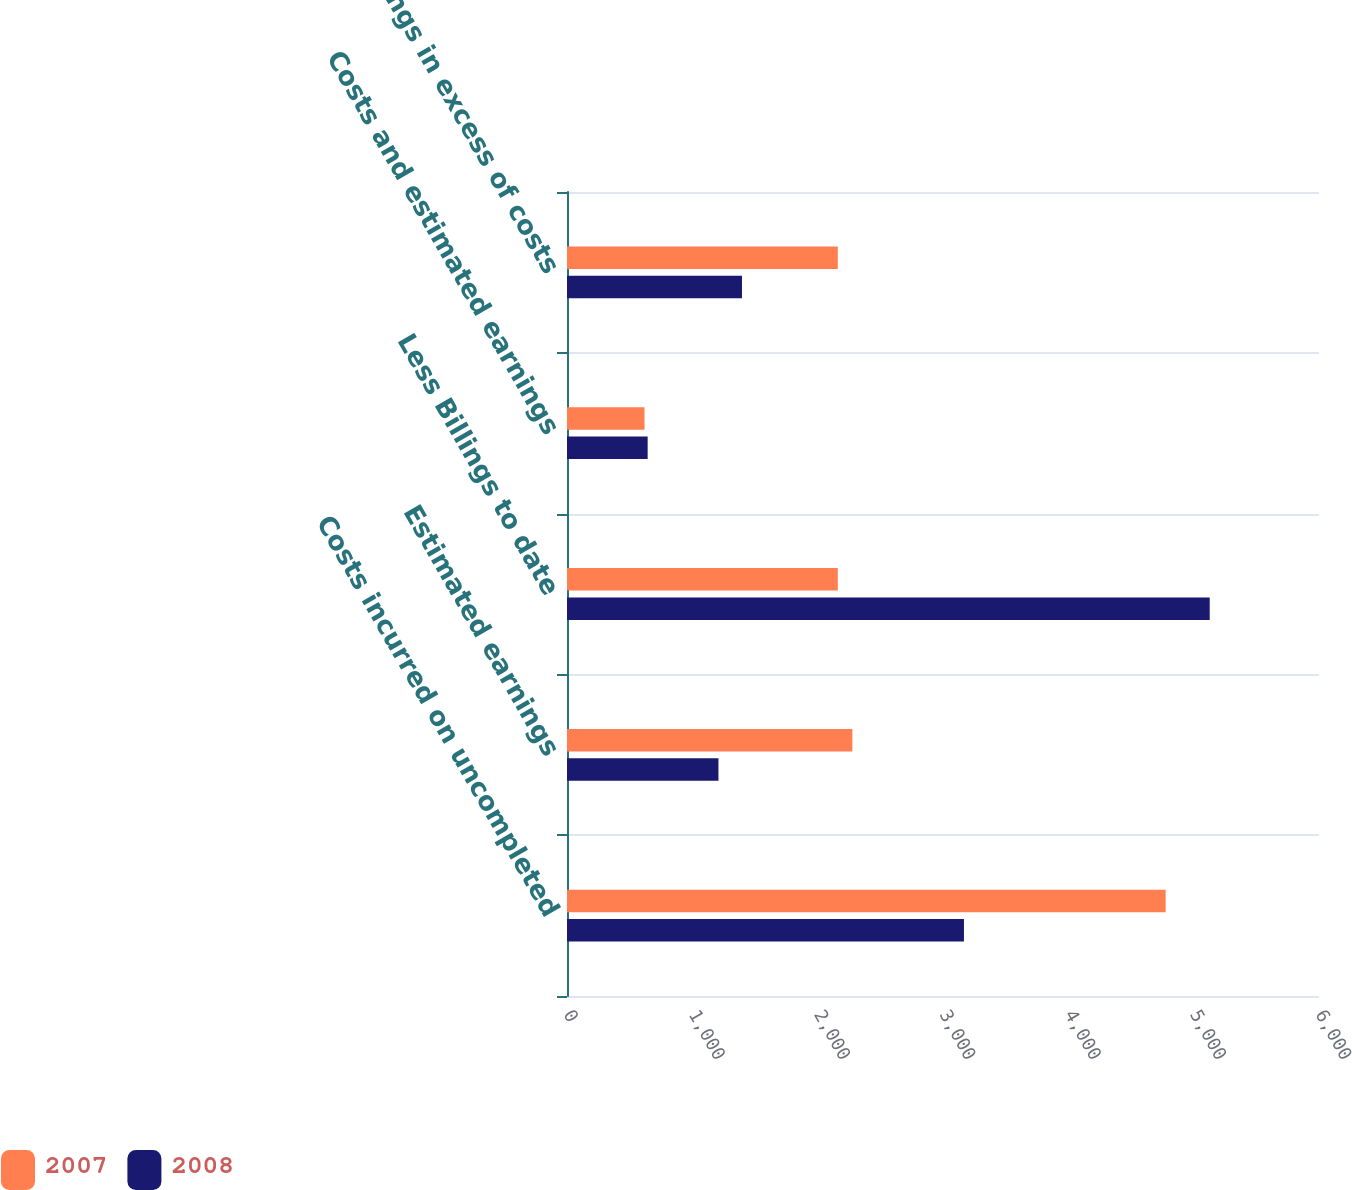<chart> <loc_0><loc_0><loc_500><loc_500><stacked_bar_chart><ecel><fcel>Costs incurred on uncompleted<fcel>Estimated earnings<fcel>Less Billings to date<fcel>Costs and estimated earnings<fcel>Billings in excess of costs<nl><fcel>2007<fcel>4776.6<fcel>2277<fcel>2160.7<fcel>618.5<fcel>2160.7<nl><fcel>2008<fcel>3167.2<fcel>1208.3<fcel>5128.1<fcel>643.5<fcel>1396.1<nl></chart> 